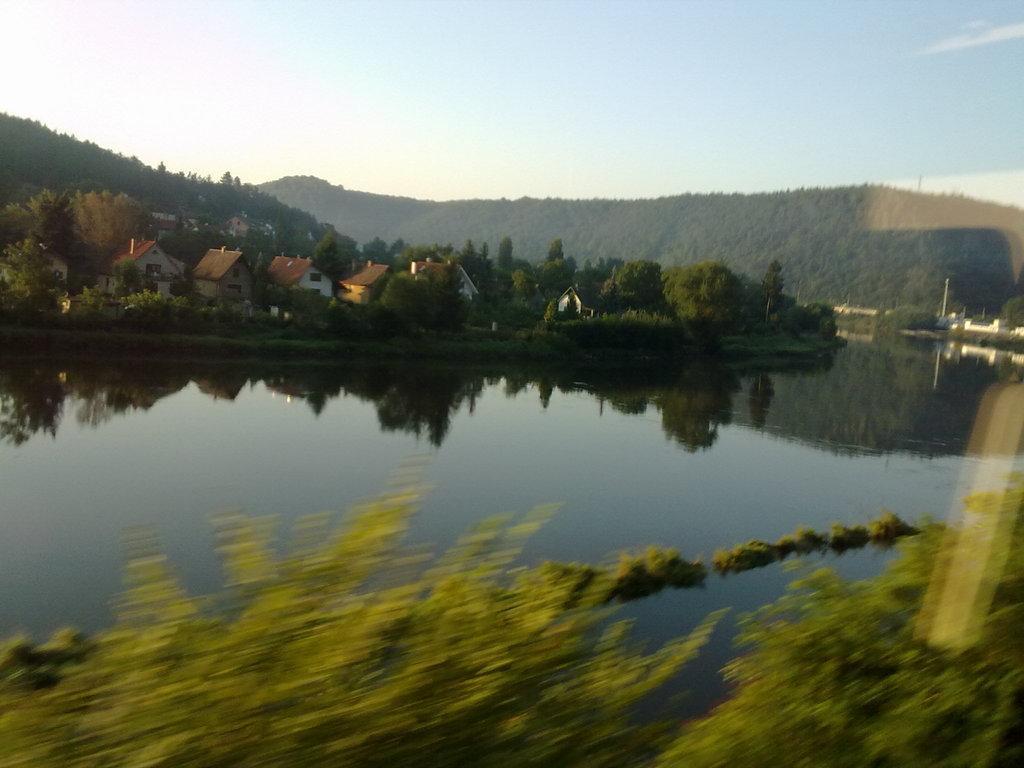In one or two sentences, can you explain what this image depicts? In the picture we can see water near to it we can see some plants and far from it we can see trees, houses and sky. 